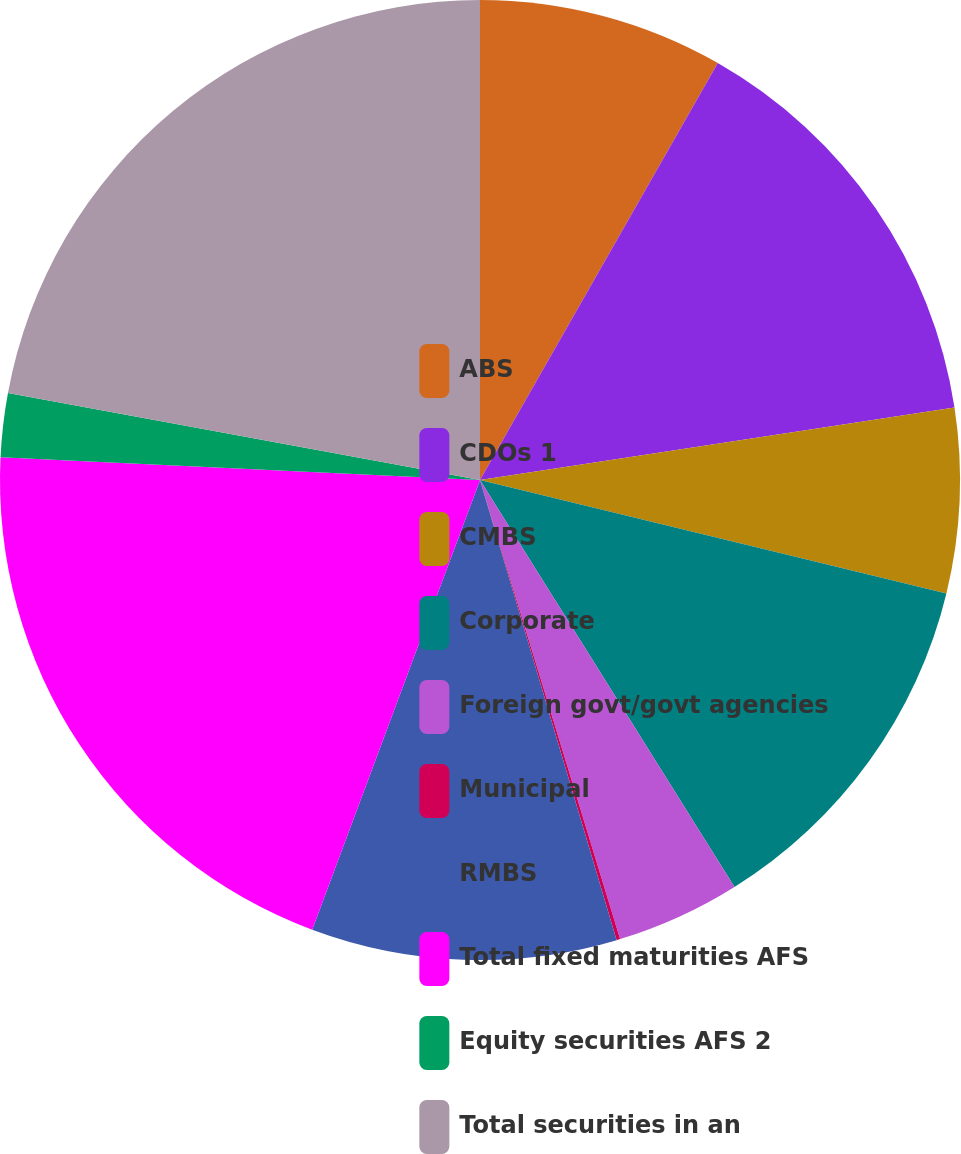<chart> <loc_0><loc_0><loc_500><loc_500><pie_chart><fcel>ABS<fcel>CDOs 1<fcel>CMBS<fcel>Corporate<fcel>Foreign govt/govt agencies<fcel>Municipal<fcel>RMBS<fcel>Total fixed maturities AFS<fcel>Equity securities AFS 2<fcel>Total securities in an<nl><fcel>8.25%<fcel>14.34%<fcel>6.21%<fcel>12.31%<fcel>4.18%<fcel>0.12%<fcel>10.28%<fcel>20.07%<fcel>2.15%<fcel>22.1%<nl></chart> 